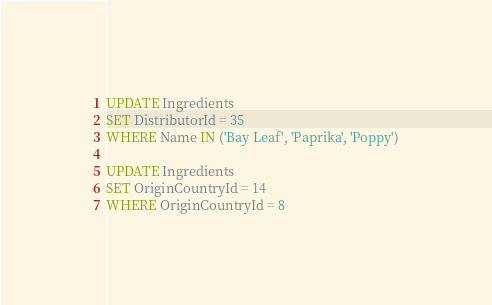Convert code to text. <code><loc_0><loc_0><loc_500><loc_500><_SQL_>UPDATE Ingredients
SET DistributorId = 35
WHERE Name IN ('Bay Leaf', 'Paprika', 'Poppy')

UPDATE Ingredients
SET OriginCountryId = 14
WHERE OriginCountryId = 8</code> 